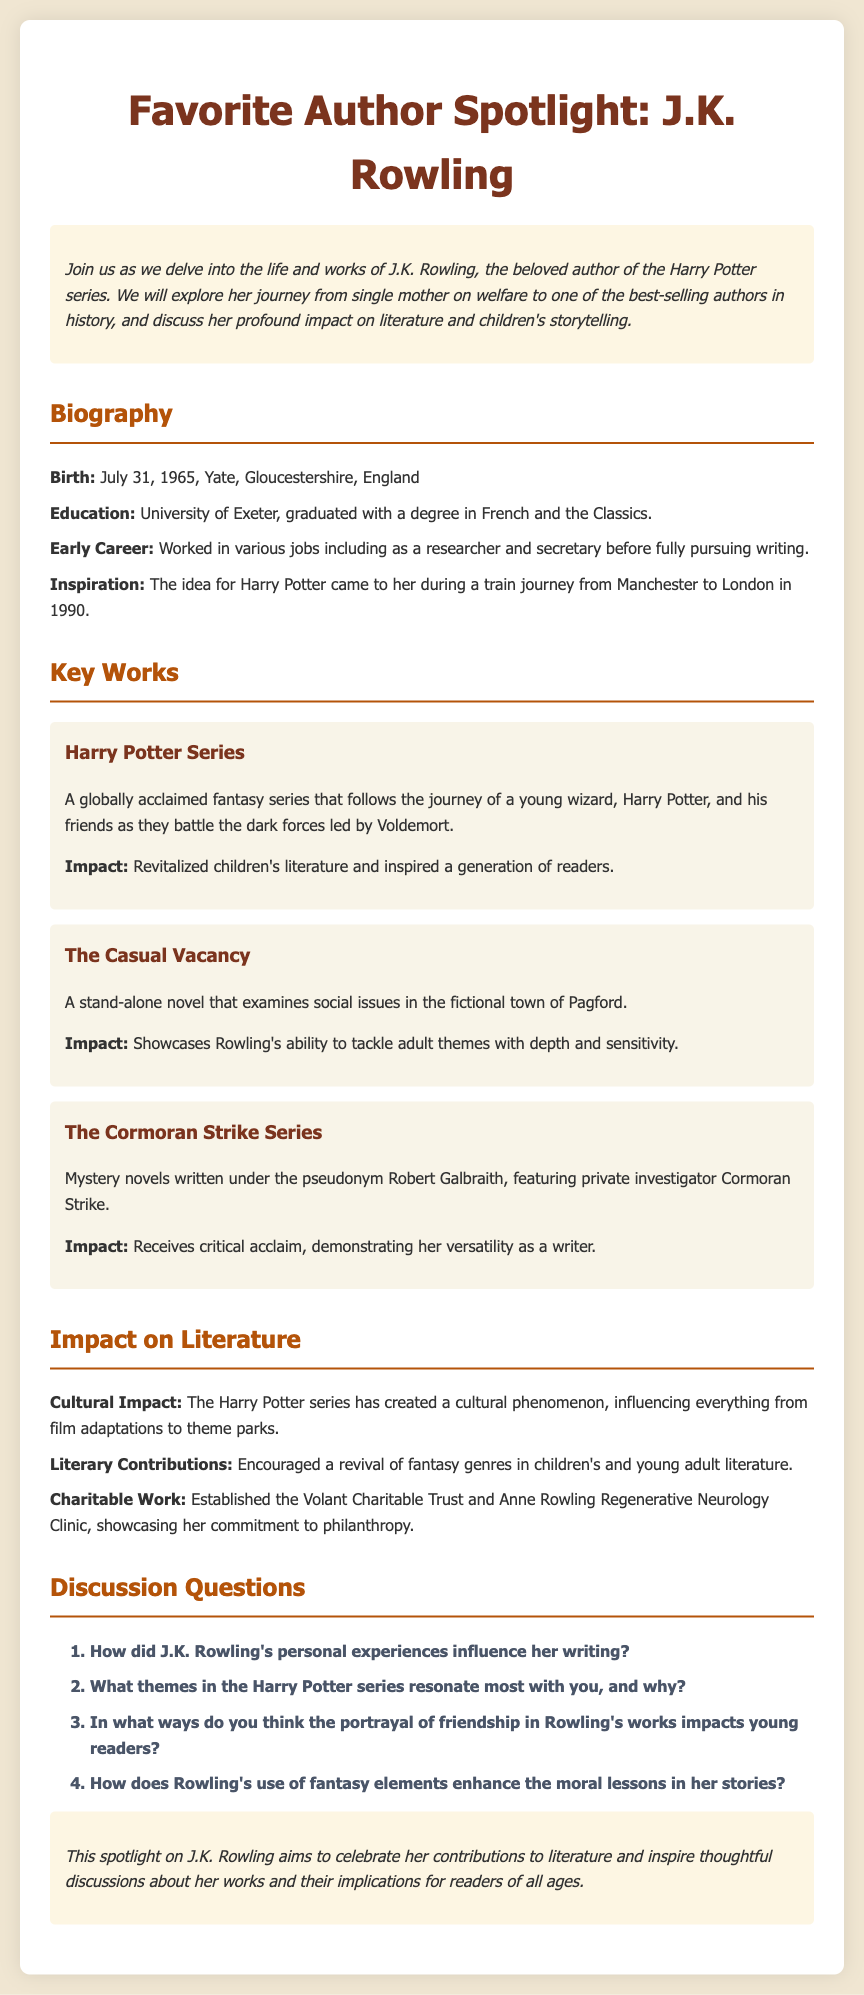What is the birthdate of J.K. Rowling? The birthdate of J.K. Rowling is mentioned in the biography section, specifically as July 31, 1965.
Answer: July 31, 1965 What university did J.K. Rowling graduate from? The document states that J.K. Rowling graduated from the University of Exeter.
Answer: University of Exeter What is the title of the stand-alone novel by J.K. Rowling? The stand-alone novel mentioned in the key works section is titled "The Casual Vacancy."
Answer: The Casual Vacancy How many books are in the Harry Potter series? The document does not specify the number of books, but it references it as a series, implying multiple installments.
Answer: (multiple) What is the main theme explored in "The Casual Vacancy"? It is stated that "The Casual Vacancy" examines social issues.
Answer: Social issues What is the pseudonym used by J.K. Rowling for writing the Cormoran Strike series? The pseudonym for the Cormoran Strike series is Robert Galbraith.
Answer: Robert Galbraith What genre revived by J.K. Rowling impacts children's literature? The document mentions that her works encouraged a revival in the fantasy genre for children's literature.
Answer: Fantasy How does the Harry Potter series influence popular culture? The document states that the series created a cultural phenomenon, influencing film adaptations and theme parks.
Answer: Cultural phenomenon What type of work has J.K. Rowling committed to in her charitable efforts? The document lists the establishment of the Volant Charitable Trust as part of her charitable work.
Answer: Volant Charitable Trust 